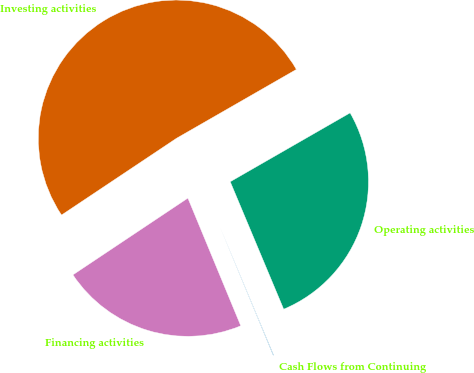Convert chart. <chart><loc_0><loc_0><loc_500><loc_500><pie_chart><fcel>Cash Flows from Continuing<fcel>Operating activities<fcel>Investing activities<fcel>Financing activities<nl><fcel>0.07%<fcel>26.98%<fcel>51.07%<fcel>21.88%<nl></chart> 